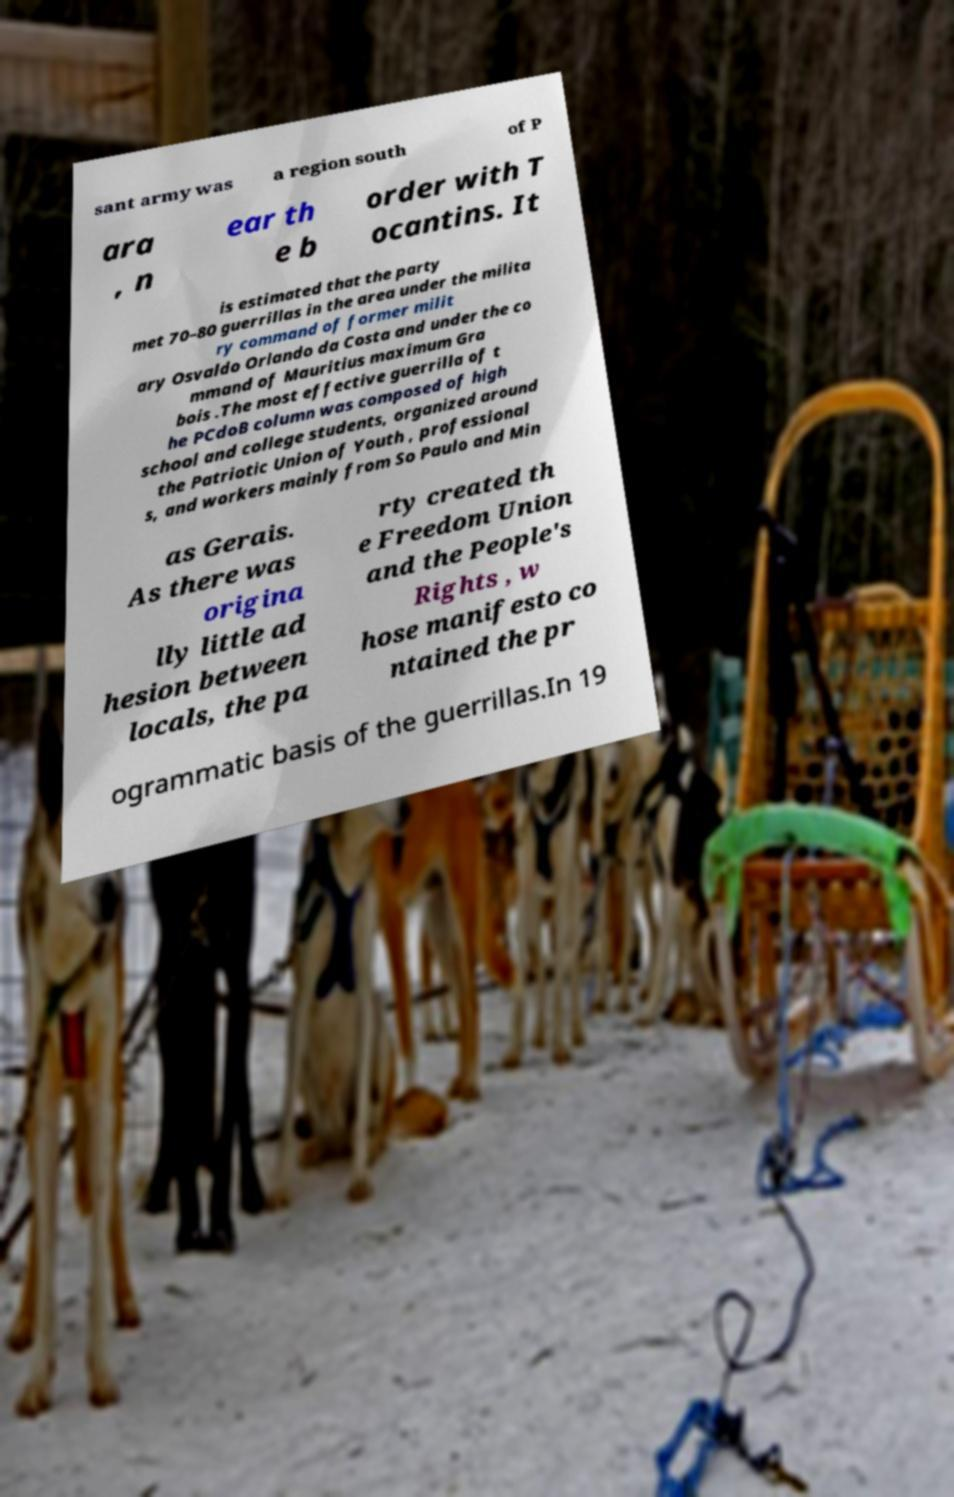I need the written content from this picture converted into text. Can you do that? sant army was a region south of P ara , n ear th e b order with T ocantins. It is estimated that the party met 70–80 guerrillas in the area under the milita ry command of former milit ary Osvaldo Orlando da Costa and under the co mmand of Mauritius maximum Gra bois .The most effective guerrilla of t he PCdoB column was composed of high school and college students, organized around the Patriotic Union of Youth , professional s, and workers mainly from So Paulo and Min as Gerais. As there was origina lly little ad hesion between locals, the pa rty created th e Freedom Union and the People's Rights , w hose manifesto co ntained the pr ogrammatic basis of the guerrillas.In 19 